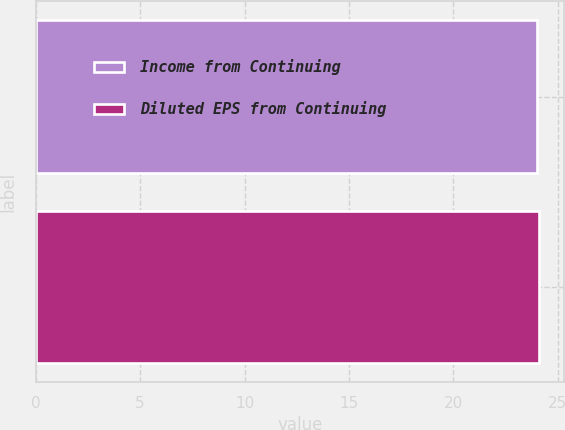Convert chart. <chart><loc_0><loc_0><loc_500><loc_500><bar_chart><fcel>Income from Continuing<fcel>Diluted EPS from Continuing<nl><fcel>24<fcel>24.1<nl></chart> 